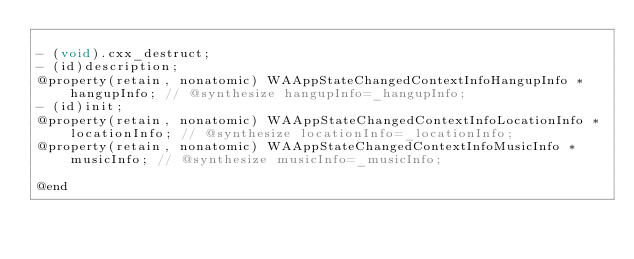Convert code to text. <code><loc_0><loc_0><loc_500><loc_500><_C_>
- (void).cxx_destruct;
- (id)description;
@property(retain, nonatomic) WAAppStateChangedContextInfoHangupInfo *hangupInfo; // @synthesize hangupInfo=_hangupInfo;
- (id)init;
@property(retain, nonatomic) WAAppStateChangedContextInfoLocationInfo *locationInfo; // @synthesize locationInfo=_locationInfo;
@property(retain, nonatomic) WAAppStateChangedContextInfoMusicInfo *musicInfo; // @synthesize musicInfo=_musicInfo;

@end

</code> 